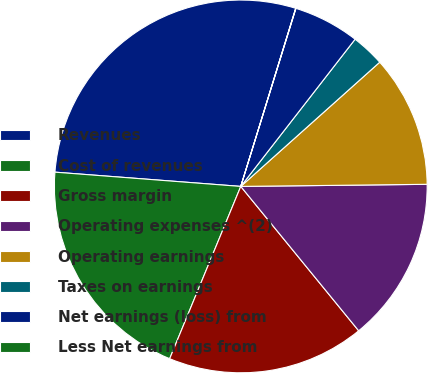Convert chart. <chart><loc_0><loc_0><loc_500><loc_500><pie_chart><fcel>Revenues<fcel>Cost of revenues<fcel>Gross margin<fcel>Operating expenses ^(2)<fcel>Operating earnings<fcel>Taxes on earnings<fcel>Net earnings (loss) from<fcel>Less Net earnings from<nl><fcel>28.54%<fcel>19.99%<fcel>17.13%<fcel>14.28%<fcel>11.43%<fcel>2.88%<fcel>5.73%<fcel>0.02%<nl></chart> 